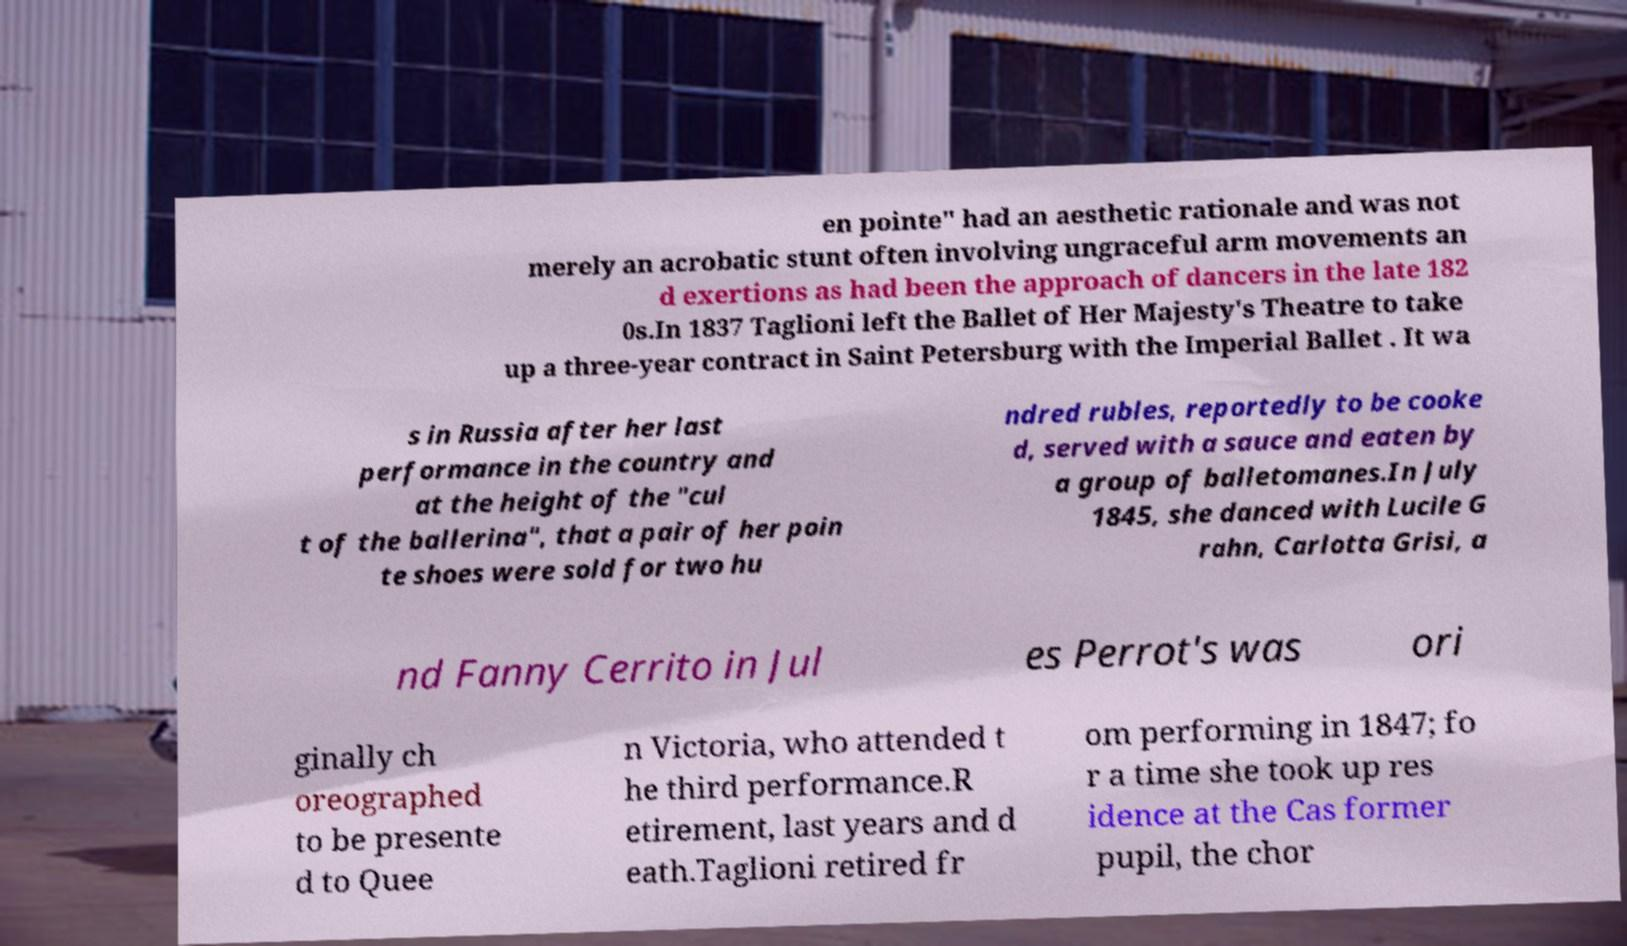There's text embedded in this image that I need extracted. Can you transcribe it verbatim? en pointe" had an aesthetic rationale and was not merely an acrobatic stunt often involving ungraceful arm movements an d exertions as had been the approach of dancers in the late 182 0s.In 1837 Taglioni left the Ballet of Her Majesty's Theatre to take up a three-year contract in Saint Petersburg with the Imperial Ballet . It wa s in Russia after her last performance in the country and at the height of the "cul t of the ballerina", that a pair of her poin te shoes were sold for two hu ndred rubles, reportedly to be cooke d, served with a sauce and eaten by a group of balletomanes.In July 1845, she danced with Lucile G rahn, Carlotta Grisi, a nd Fanny Cerrito in Jul es Perrot's was ori ginally ch oreographed to be presente d to Quee n Victoria, who attended t he third performance.R etirement, last years and d eath.Taglioni retired fr om performing in 1847; fo r a time she took up res idence at the Cas former pupil, the chor 